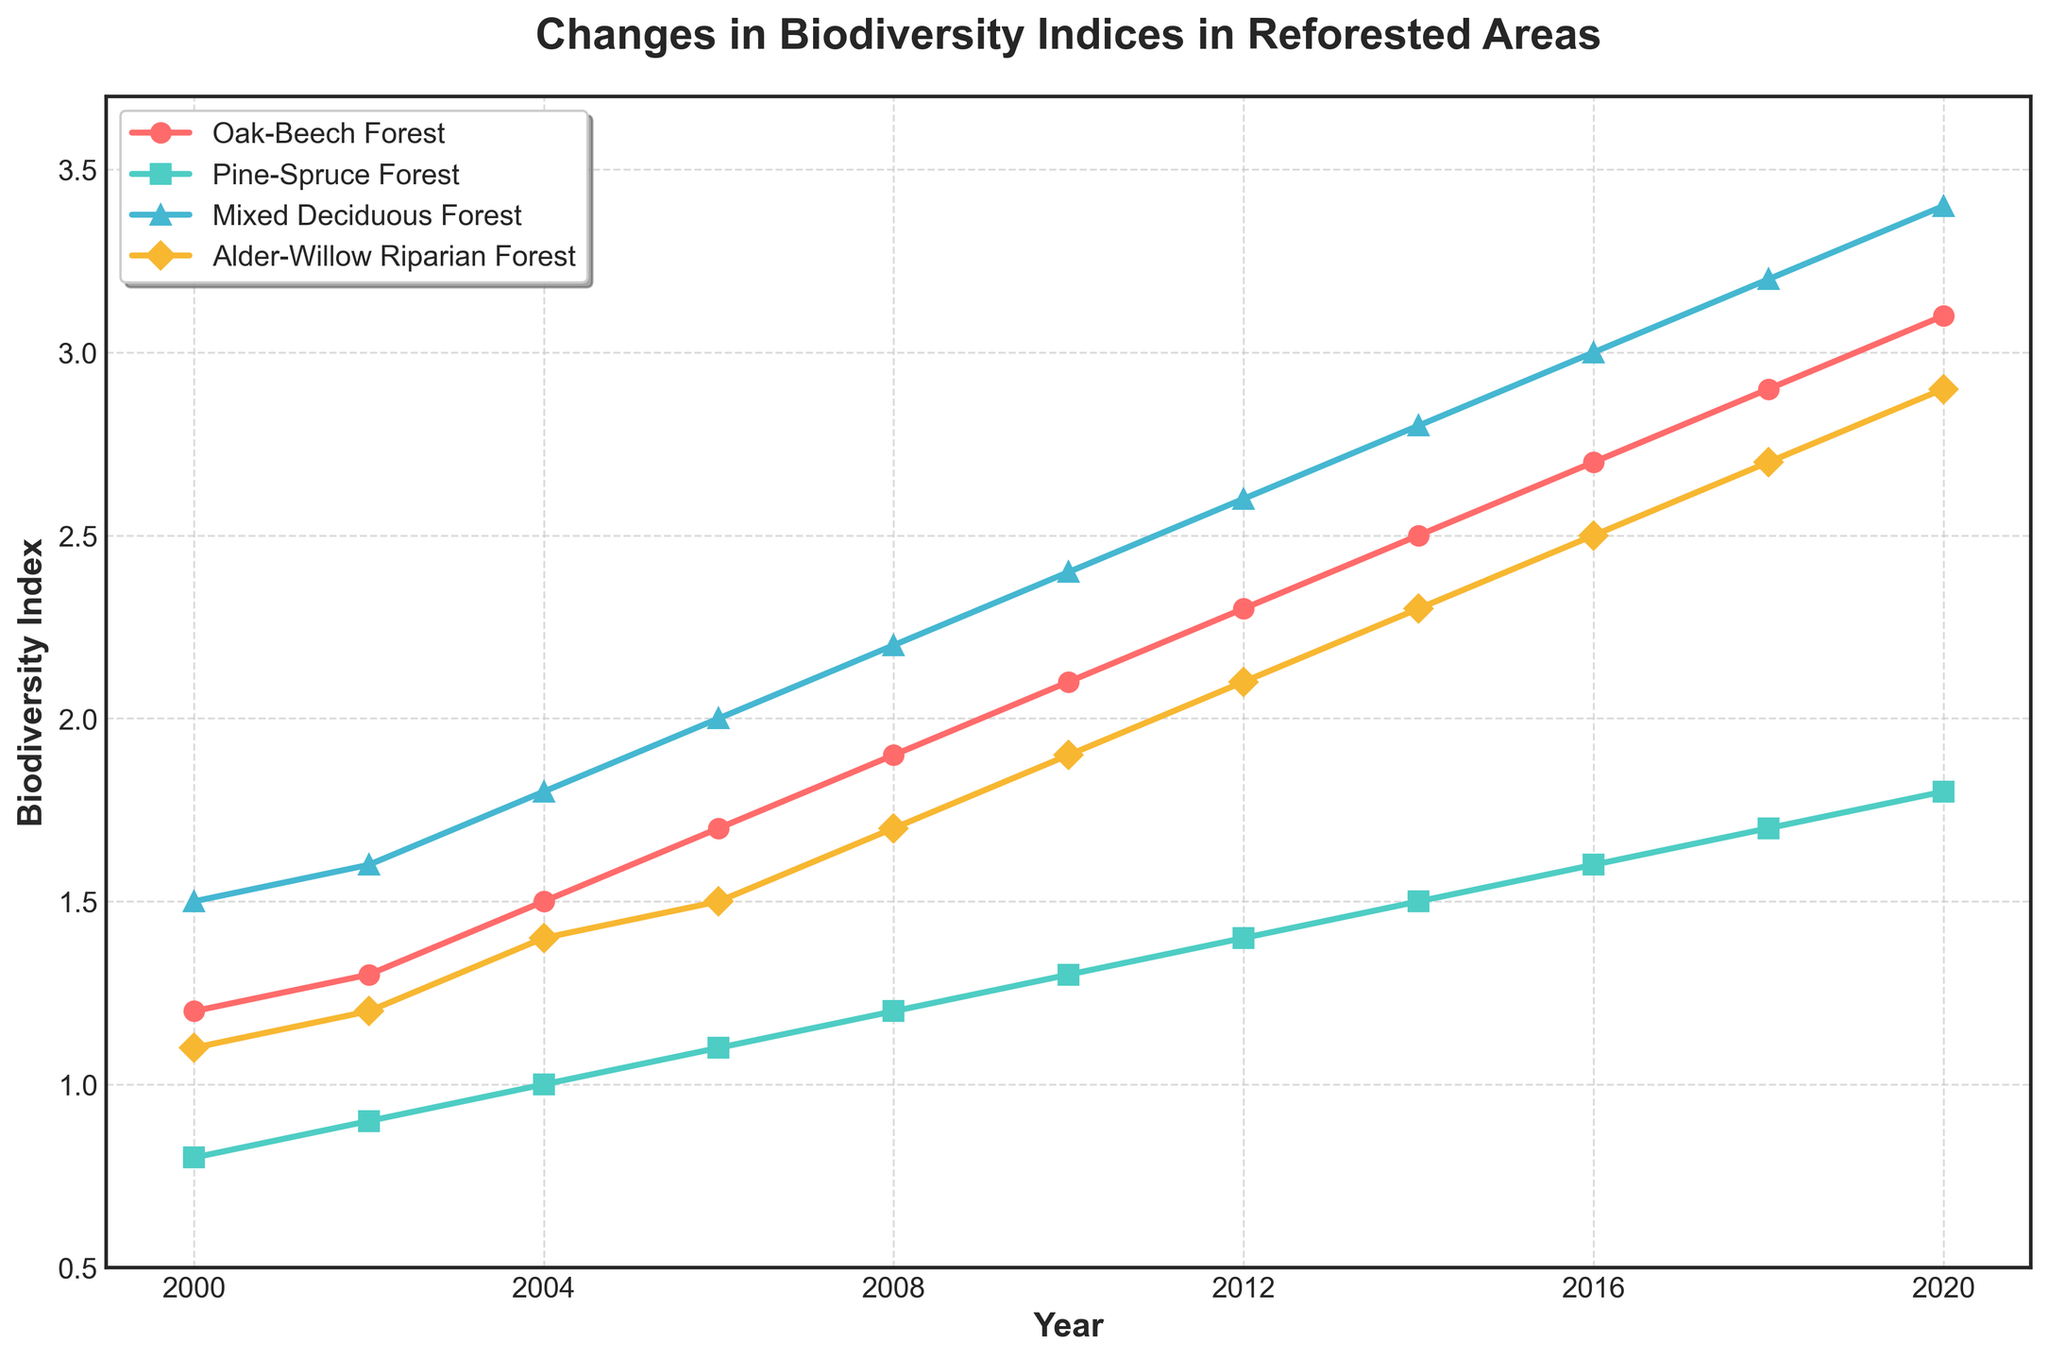how do the biodiversity indices of Oak-Beech Forest compare to Pine-Spruce Forest in the year 2020? Look at the data points for the year 2020 in the graph. The Oak-Beech Forest has a biodiversity index of 3.1, while the Pine-Spruce Forest has a biodiversity index of 1.8. Therefore, the Oak-Beech Forest has a higher biodiversity index.
Answer: The Oak-Beech Forest has a higher biodiversity index What is the general trend of the biodiversity index for the Mixed Deciduous Forest from 2000 to 2020? The biodiversity index for the Mixed Deciduous Forest consistently increases every year from 1.5 in 2000 to 3.4 in 2020, indicating a positive upward trend.
Answer: Consistently increasing trend Which forest type shows the least change in biodiversity index over the 20-year period? Identify the start and end values for each forest type. The Pine-Spruce Forest starts at 0.8 in 2000 and ends at 1.8 in 2020, making a total change of 1.0. This is the smallest change compared to the other forest types.
Answer: Pine-Spruce Forest What is the average increase in the biodiversity index of the Alder-Willow Riparian Forest between each recorded year? Each interval sees an increase. Calculate the total increase from 2.9 (2020) - 1.1 (2000) = 1.8 and there are 10 intervals (year differences). Thus, 1.8 / 10 = 0.18
Answer: 0.18 Which year marks the beginning of a rapid increase in the biodiversity index for Oak-Beech Forest? The Oak-Beech Forest shows larger year-over-year increases starting from 2002 onward. Before 2002, the increase is smaller. Thus, the year 2002 marks the beginning of this rapid increase.
Answer: 2002 In which period did the Mixed-Deciduous forest see the largest increase in biodiversity index? Calculate the differences for each time interval for Mixed-Deciduous Forest: 1.5 in 2000, 1.6 in 2002 (0.1 increase), ..., 3.4 - 3.2 in 2018 (0.2 increase). The largest change is between 2000 to 2002 and 2018 to 2020
Answer: 2018 to 2020 Which forest type had the highest biodiversity index in 2010, and what was it? In 2010, check the biodiversity indices: Oak-Beech (2.1), Pine-Spruce (1.3), Mixed Deciduous (2.4), Alder-Willow Riparian (1.9). The highest one is for Mixed Deciduous Forest
Answer: Mixed Deciduous Forest, 2.4 Are there any forest types that did not reach a biodiversity index of 2.0 by 2020? By 2020, the Pine-Spruce Forest has a biodiversity index of 1.8, which is the only type that didn't reach 2.0.
Answer: Pine-Spruce Forest 